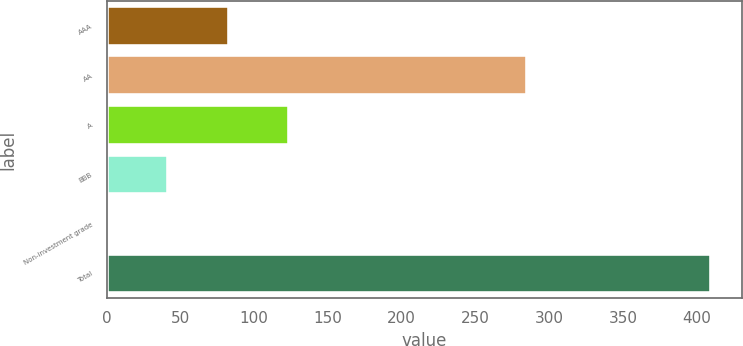Convert chart. <chart><loc_0><loc_0><loc_500><loc_500><bar_chart><fcel>AAA<fcel>AA<fcel>A<fcel>BBB<fcel>Non-investment grade<fcel>Total<nl><fcel>82.8<fcel>285<fcel>123.7<fcel>41.9<fcel>1<fcel>410<nl></chart> 